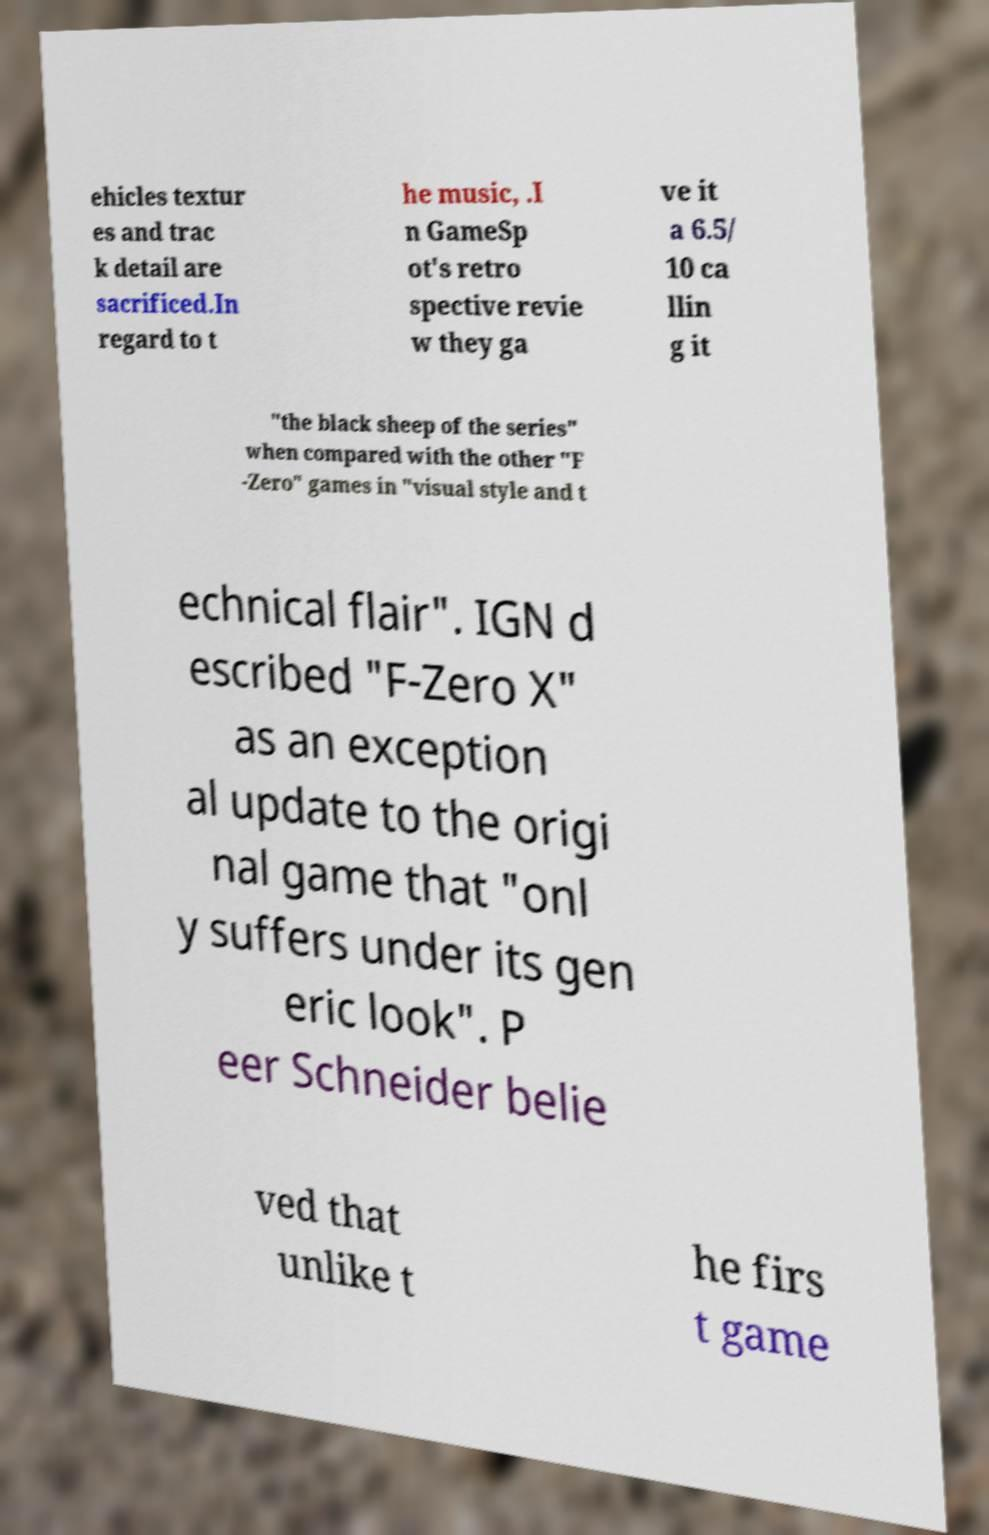What messages or text are displayed in this image? I need them in a readable, typed format. ehicles textur es and trac k detail are sacrificed.In regard to t he music, .I n GameSp ot's retro spective revie w they ga ve it a 6.5/ 10 ca llin g it "the black sheep of the series" when compared with the other "F -Zero" games in "visual style and t echnical flair". IGN d escribed "F-Zero X" as an exception al update to the origi nal game that "onl y suffers under its gen eric look". P eer Schneider belie ved that unlike t he firs t game 